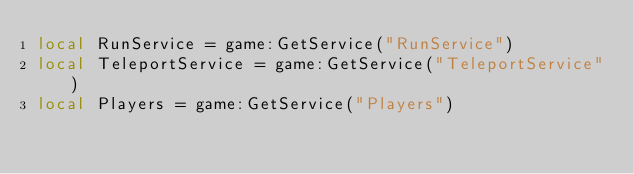<code> <loc_0><loc_0><loc_500><loc_500><_Lua_>local RunService = game:GetService("RunService")
local TeleportService = game:GetService("TeleportService")
local Players = game:GetService("Players")</code> 